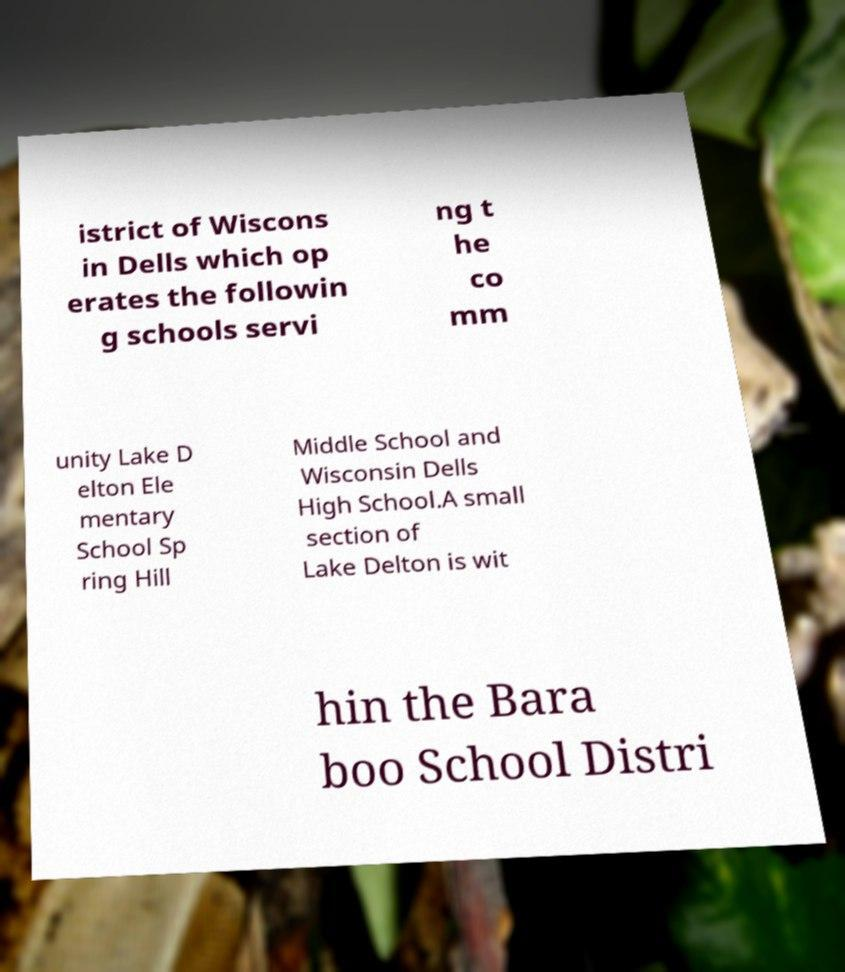Could you assist in decoding the text presented in this image and type it out clearly? istrict of Wiscons in Dells which op erates the followin g schools servi ng t he co mm unity Lake D elton Ele mentary School Sp ring Hill Middle School and Wisconsin Dells High School.A small section of Lake Delton is wit hin the Bara boo School Distri 